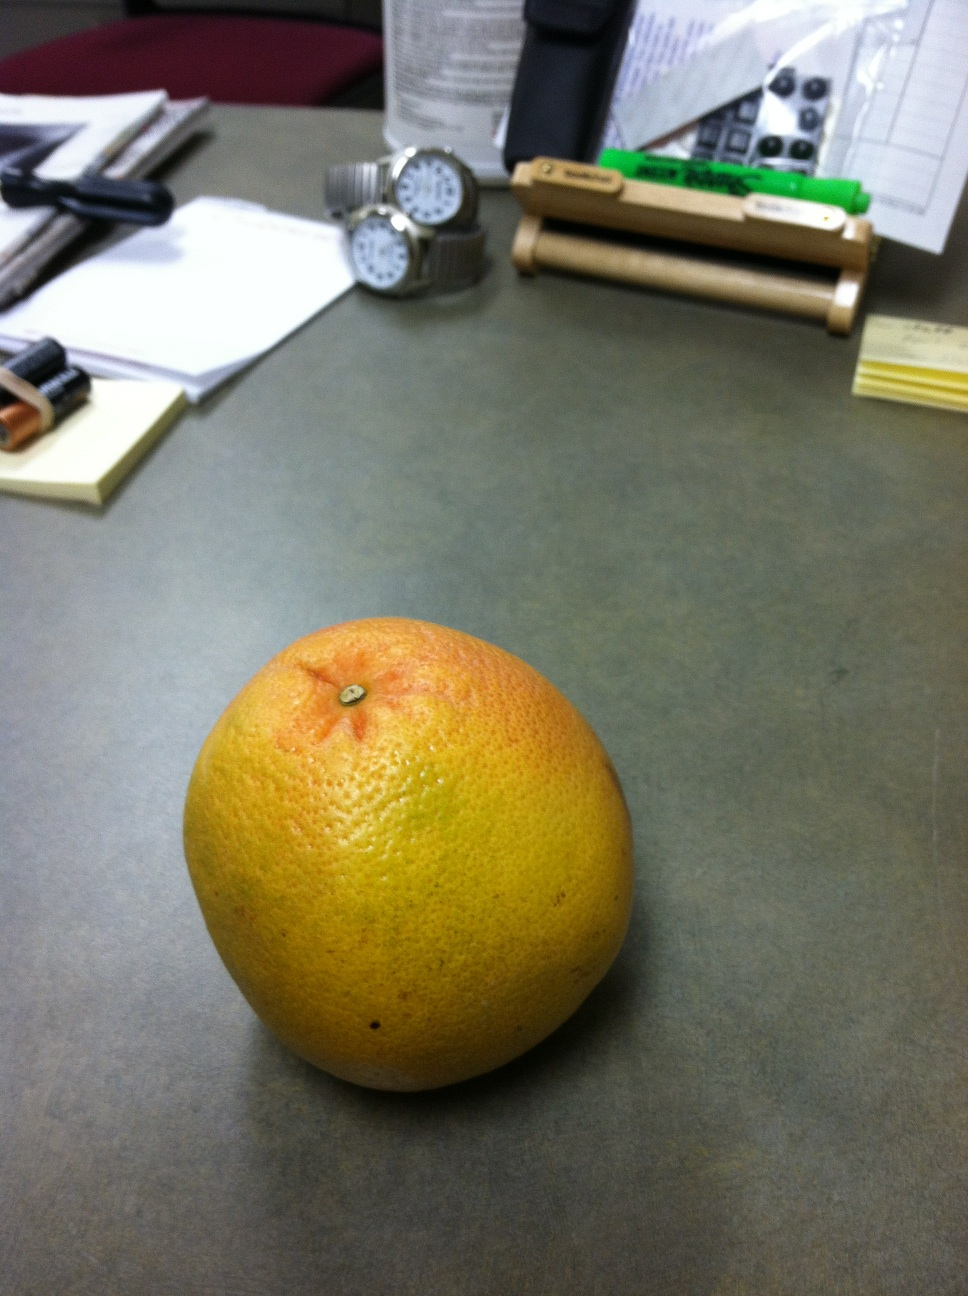What color is this? This is a grapefruit, and its color is a gradient ranging from yellow to a pinkish-orange, which is typical for this type of fruit. The colors can vary depending on the specific variety and ripeness. 